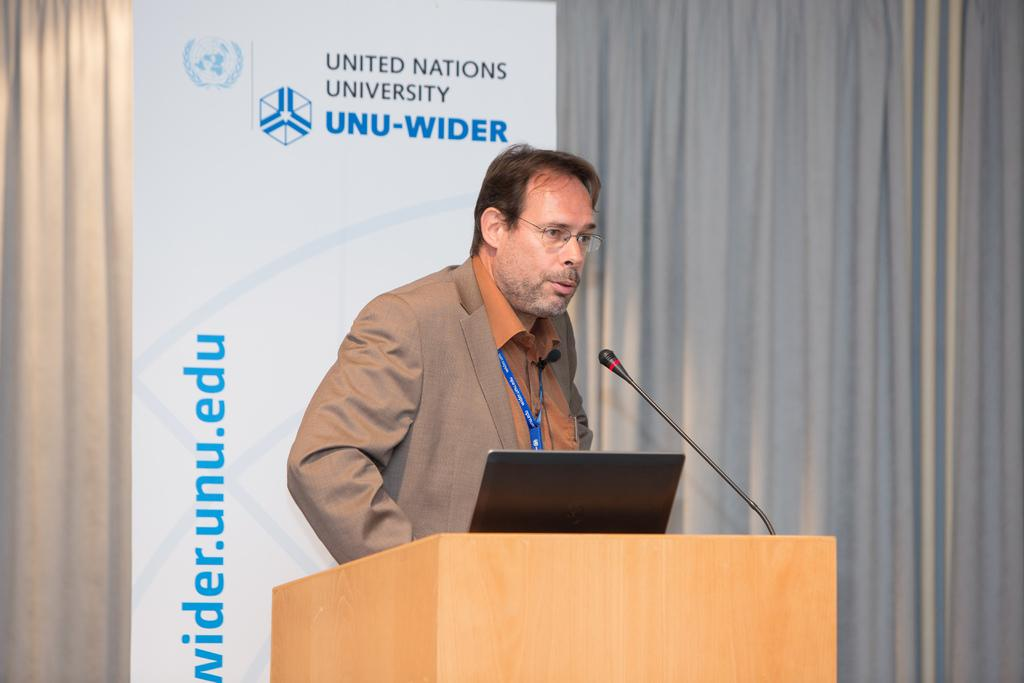What is the person in the image doing? The person is standing in front of a podium and speaking. What objects are on the podium? There is a laptop and a microphone on the podium. What can be seen behind the person? There is a banner behind the person. What type of background is present in the image? There is a curtain present in the image. What type of bedroom furniture can be seen in the image? There is no bedroom furniture present in the image; it features a person standing in front of a podium with a laptop, microphone, banner, and curtain. What type of musical instruments are being played by the band in the image? There is no band present in the image; it features a person standing in front of a podium with a laptop, microphone, banner, and curtain. 